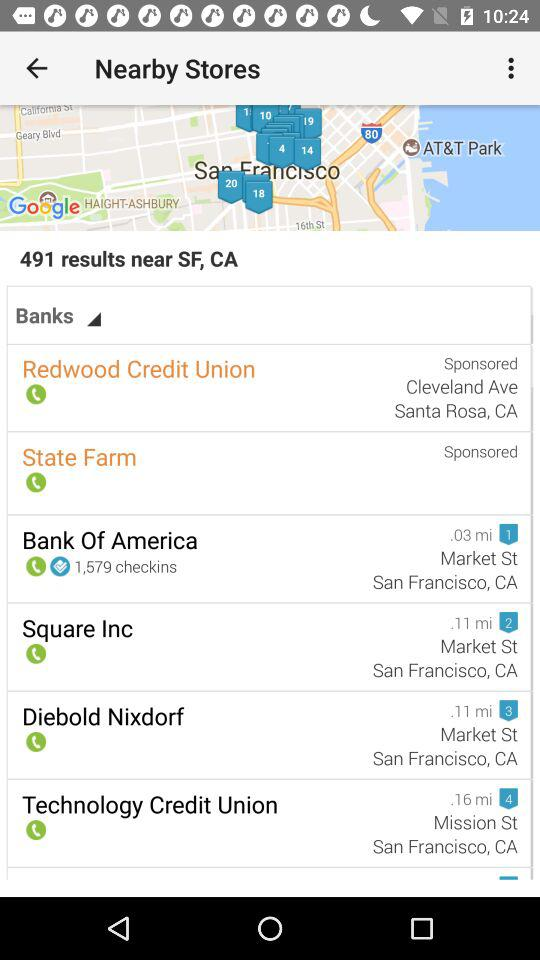Can you tell me which bank appears to have the most check-ins? Certainly! The Bank of America is shown to have the most check-ins with a total of 1,579. 